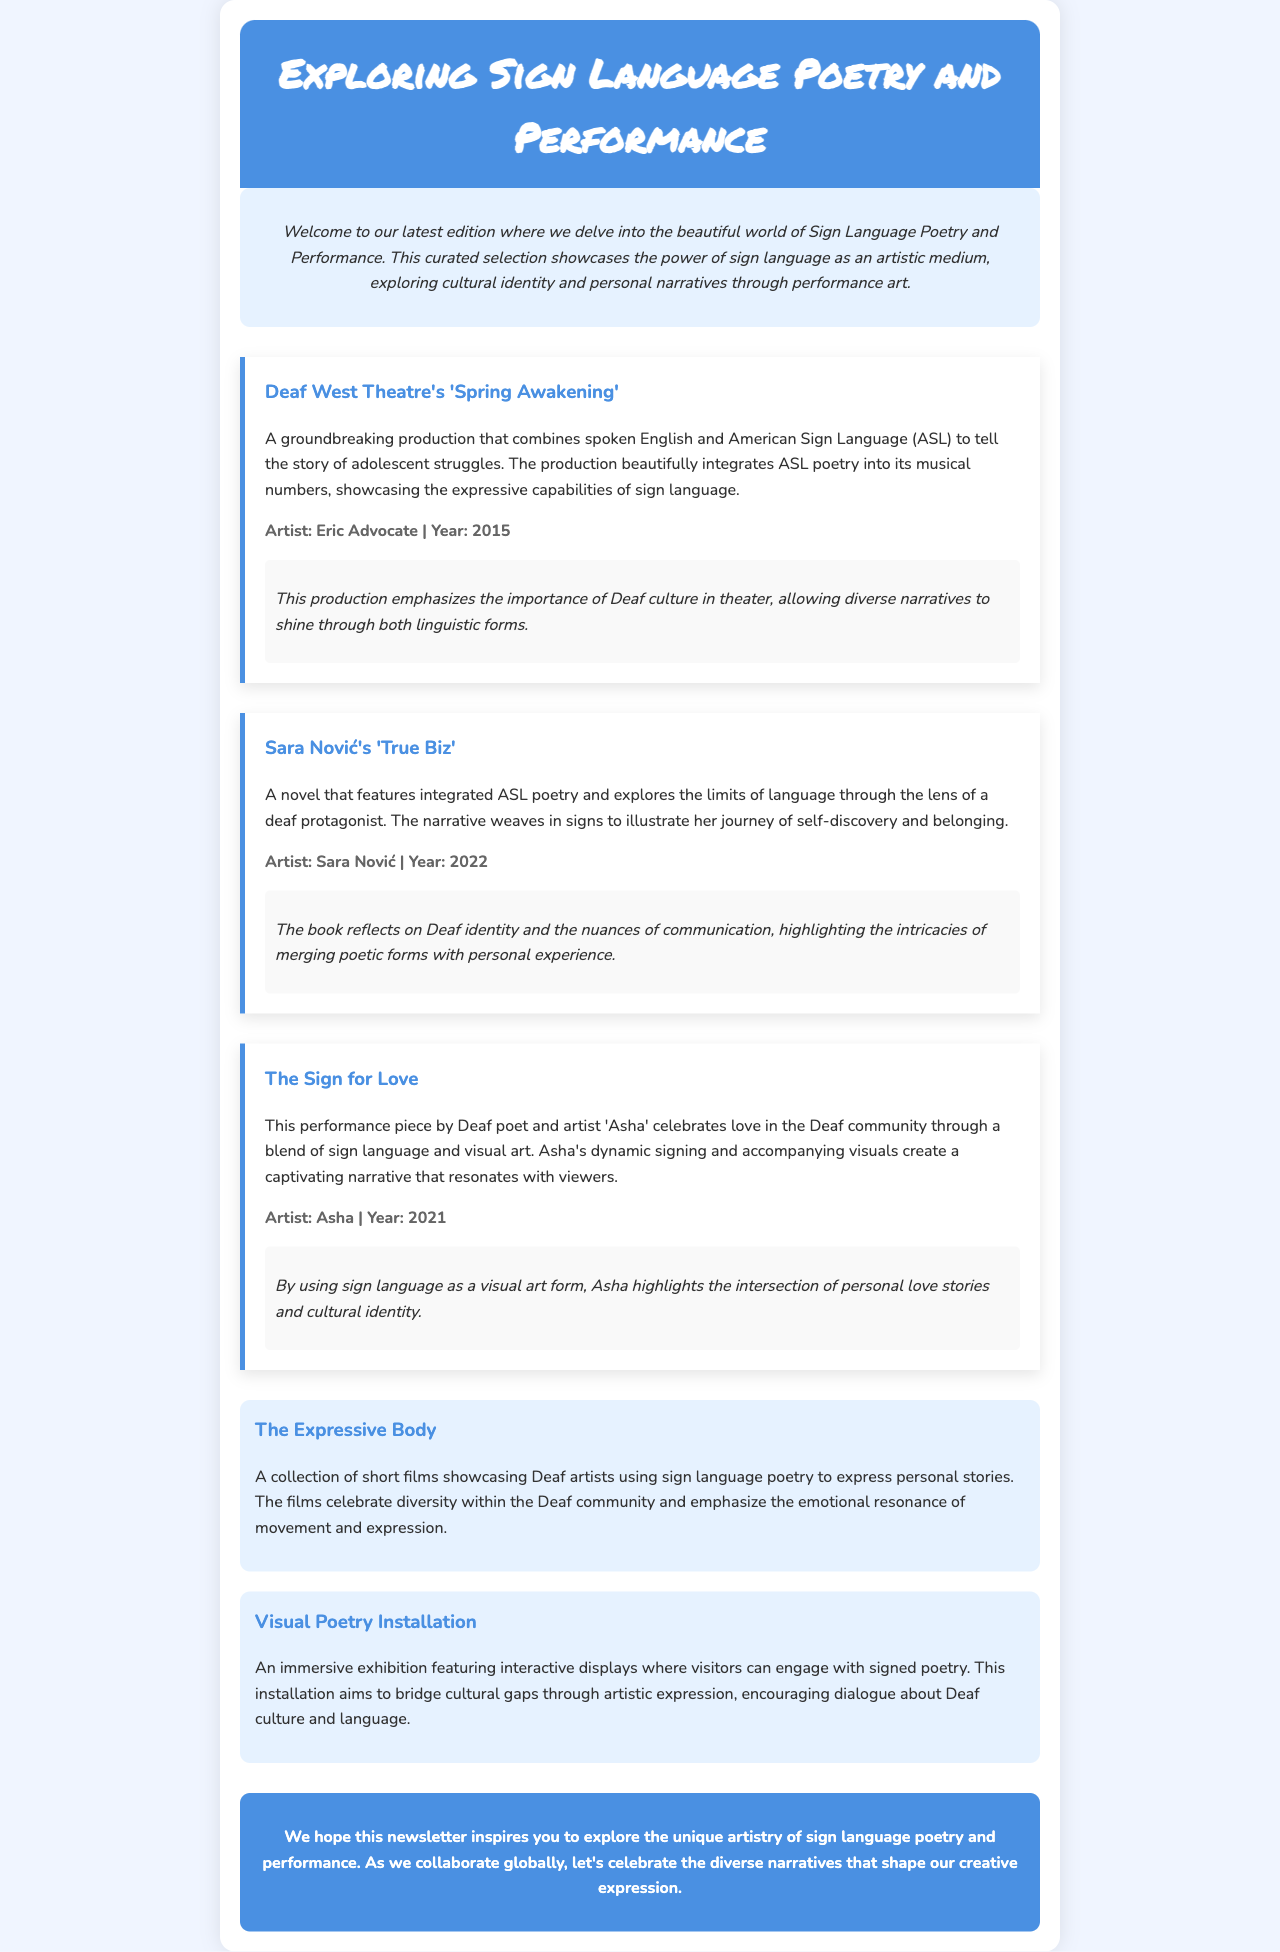What is the title of the newsletter? The title is displayed prominently at the top of the document.
Answer: Exploring Sign Language Poetry and Performance Who is the artist of 'Spring Awakening'? The artist's name is mentioned in the summary of the featured piece.
Answer: Eric Advocate What year was 'True Biz' published? The year is included in the artist information section for this particular piece.
Answer: 2022 What type of performance does 'The Sign for Love' focus on? The focus of the performance is highlighted in the piece's description.
Answer: Love How many featured pieces are mentioned in the newsletter? The number of featured pieces can be counted in the 'featured-pieces' section.
Answer: Three What is the theme of the collection titled 'The Expressive Body'? The theme is described in the overview of the creative visuals section.
Answer: Personal stories What type of exhibition is discussed in the document? The type of exhibition is specified in the description of the creative visual.
Answer: Visual Poetry Installation What cultural aspect does the newsletter aim to explore? The newsletter's purpose is outlined in the introductory section.
Answer: Cultural identity Who is the artist behind the performance piece that celebrates love? The artist's name is directly provided in the piece's details.
Answer: Asha 